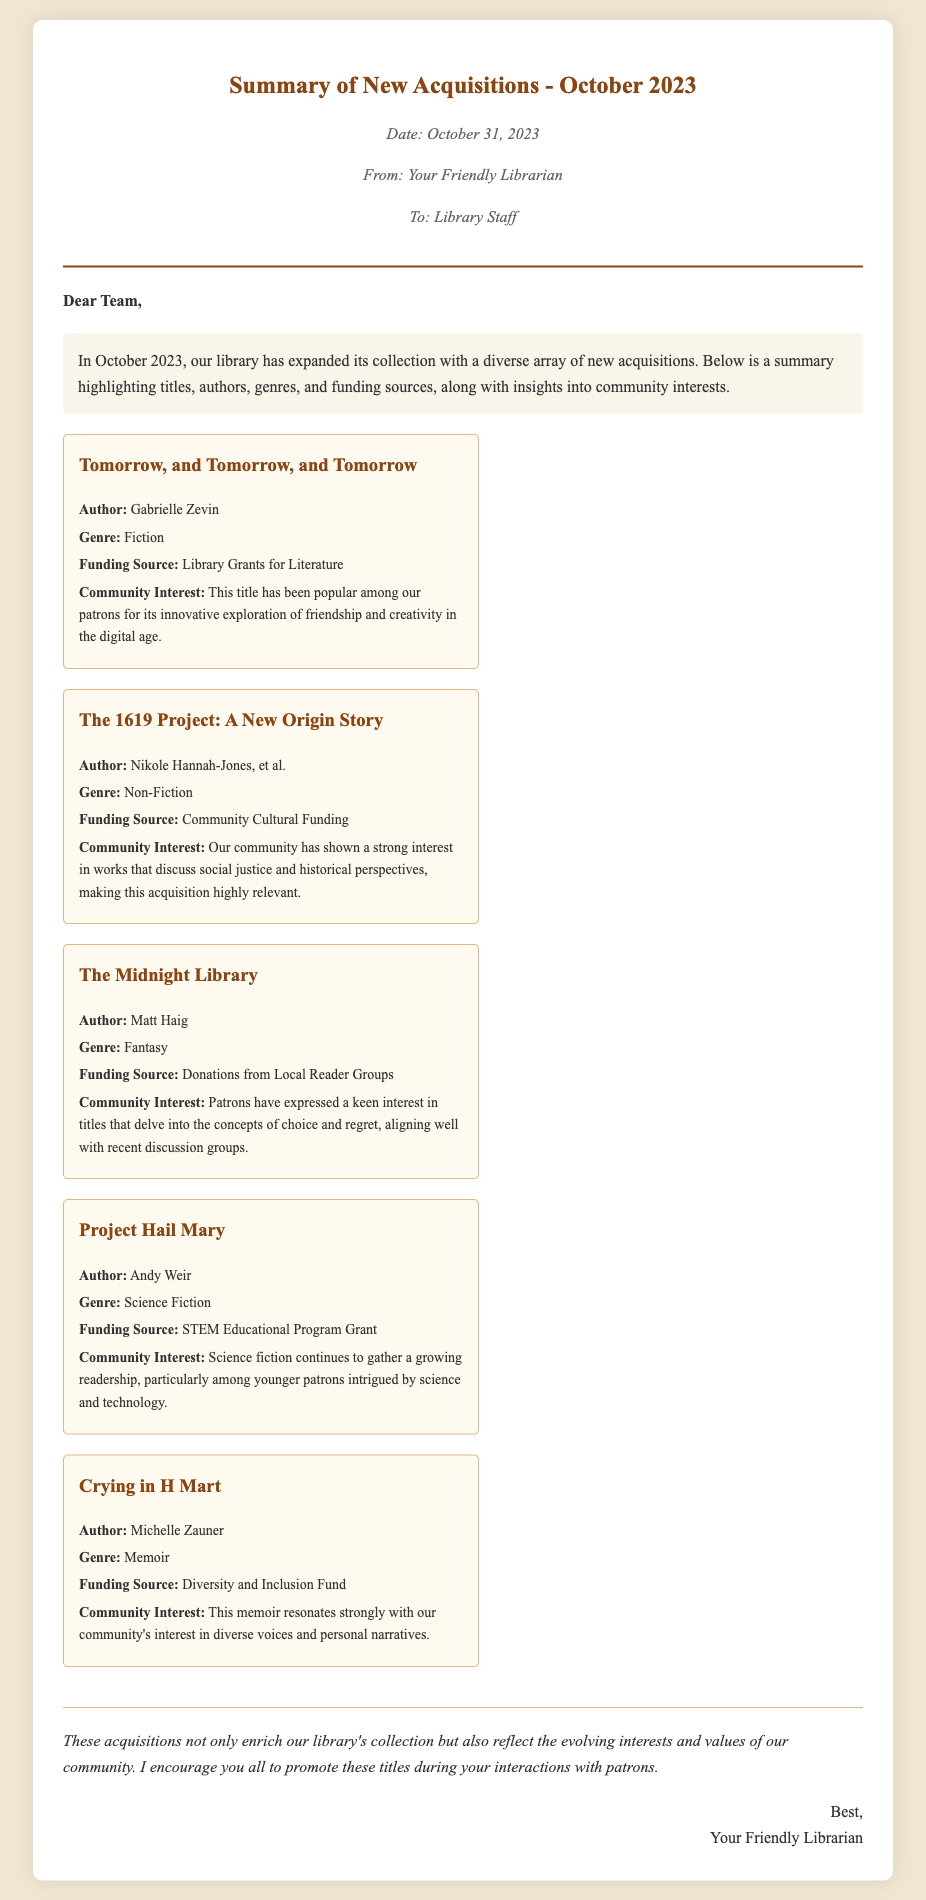what is the date of the memo? The date is mentioned at the beginning of the memo in the "meta" section.
Answer: October 31, 2023 who is the author of "Tomorrow, and Tomorrow, and Tomorrow"? The author is specified in each book section within the acquisitions list.
Answer: Gabrielle Zevin what genre is "The Midnight Library"? The genre is categorized in the acquisitions section of each title.
Answer: Fantasy which funding source supported "Crying in H Mart"? The funding source can be found in the book details under each title.
Answer: Diversity and Inclusion Fund what community interest is associated with "Project Hail Mary"? The community interest is mentioned in the description for each acquisition, summarizing patron interests.
Answer: Science fiction continues to gather a growing readership what does the summary of acquisitions indicate about community interests? The conclusion summarizes the impact of acquisitions on community interests and values, highlighting alignment with patron interests.
Answer: Evolving interests and values of our community how many new books are listed in the acquisitions? The number can be counted from the list of acquisitions in the document.
Answer: Five 